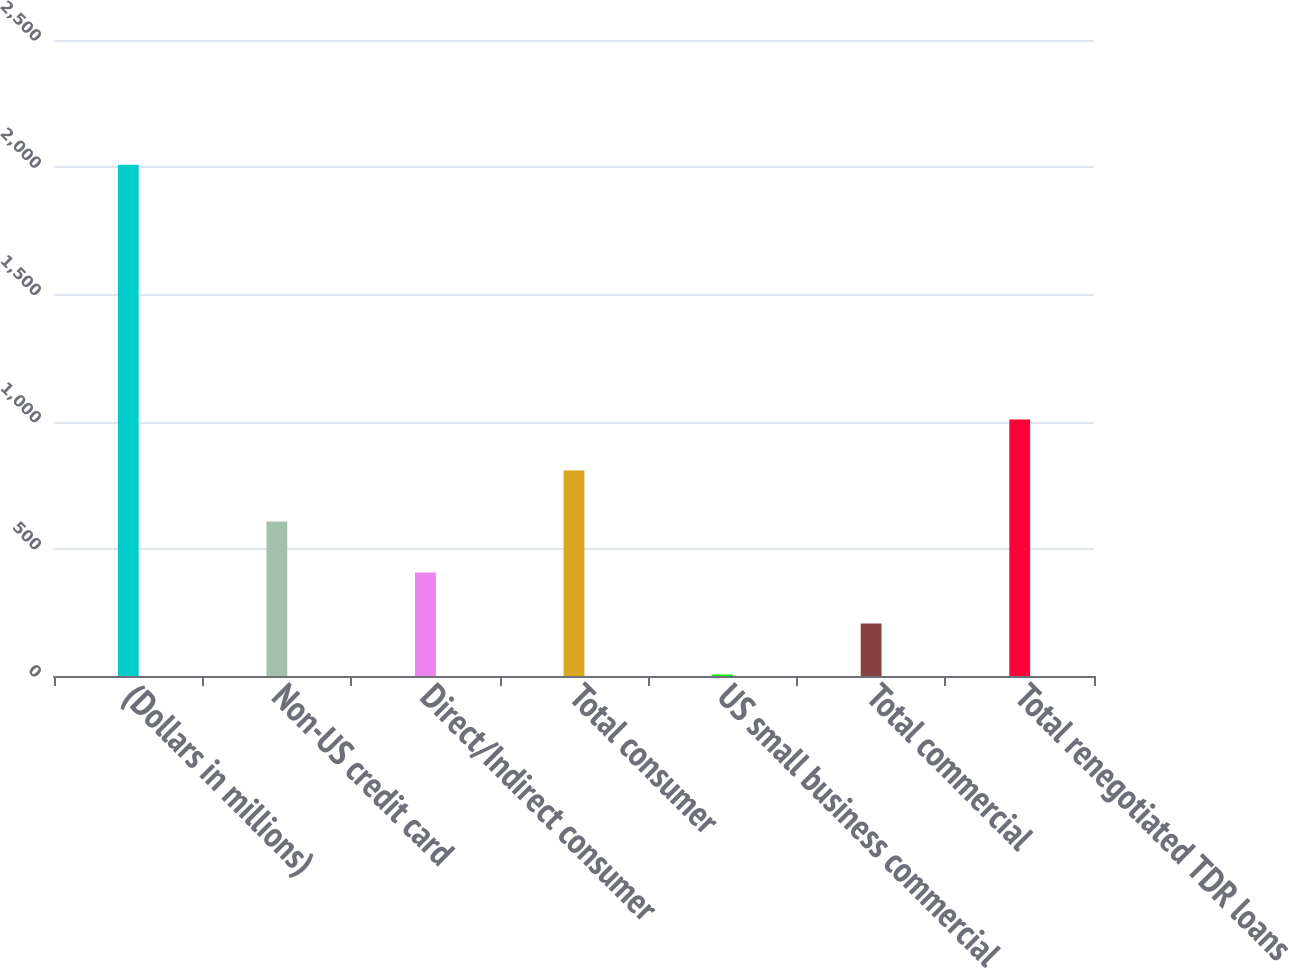Convert chart. <chart><loc_0><loc_0><loc_500><loc_500><bar_chart><fcel>(Dollars in millions)<fcel>Non-US credit card<fcel>Direct/Indirect consumer<fcel>Total consumer<fcel>US small business commercial<fcel>Total commercial<fcel>Total renegotiated TDR loans<nl><fcel>2010<fcel>607.2<fcel>406.8<fcel>807.6<fcel>6<fcel>206.4<fcel>1008<nl></chart> 